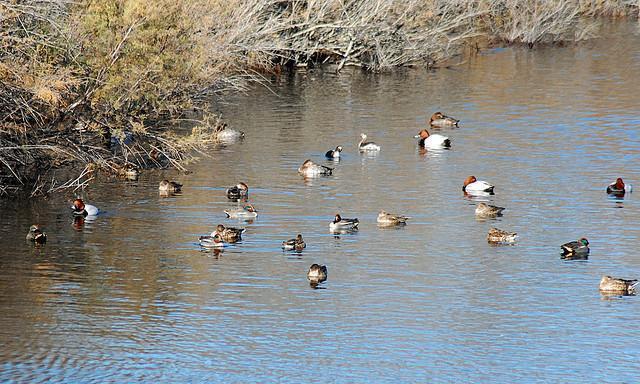What are the males called?
Answer the question by selecting the correct answer among the 4 following choices.
Options: Roosters, cocks, gander, drakes. Drakes. 